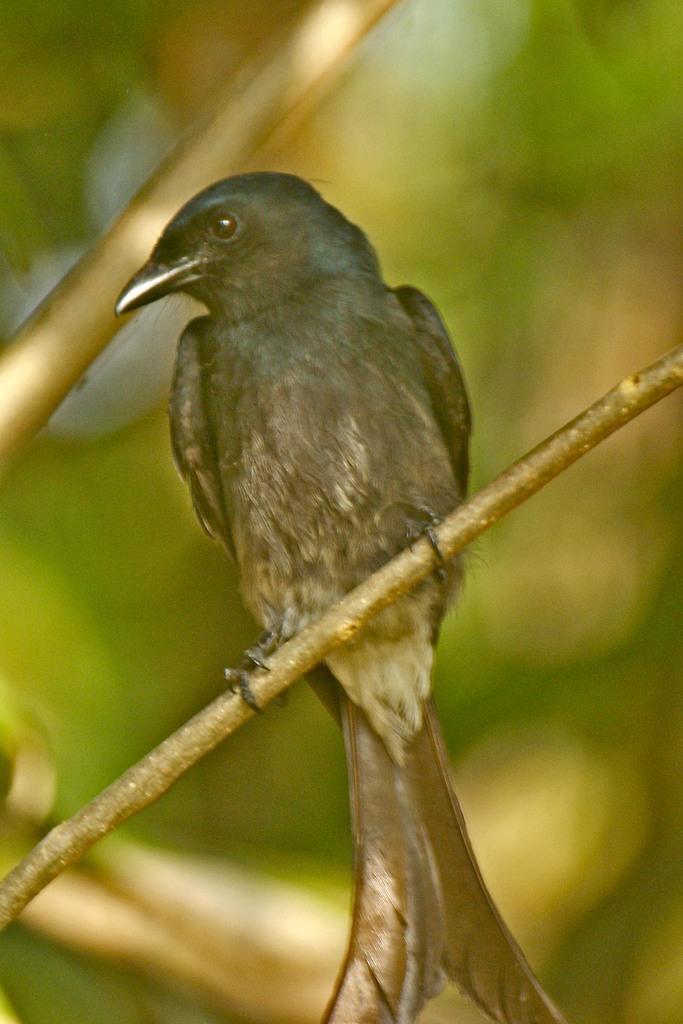Please provide a concise description of this image. In this image there is a bird on the stem. 